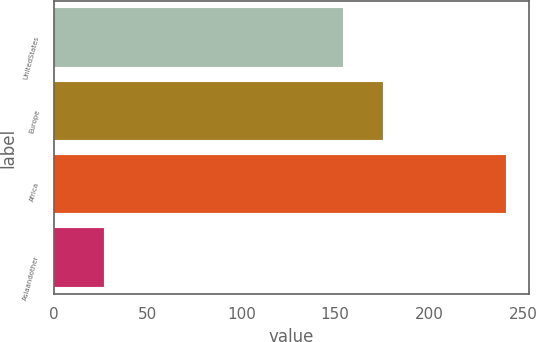Convert chart to OTSL. <chart><loc_0><loc_0><loc_500><loc_500><bar_chart><fcel>UnitedStates<fcel>Europe<fcel>Africa<fcel>Asiaandother<nl><fcel>154<fcel>175.4<fcel>241<fcel>27<nl></chart> 